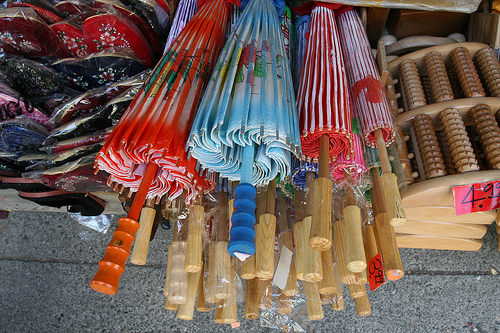<image>
Can you confirm if the handle is in the umbrella? Yes. The handle is contained within or inside the umbrella, showing a containment relationship. 